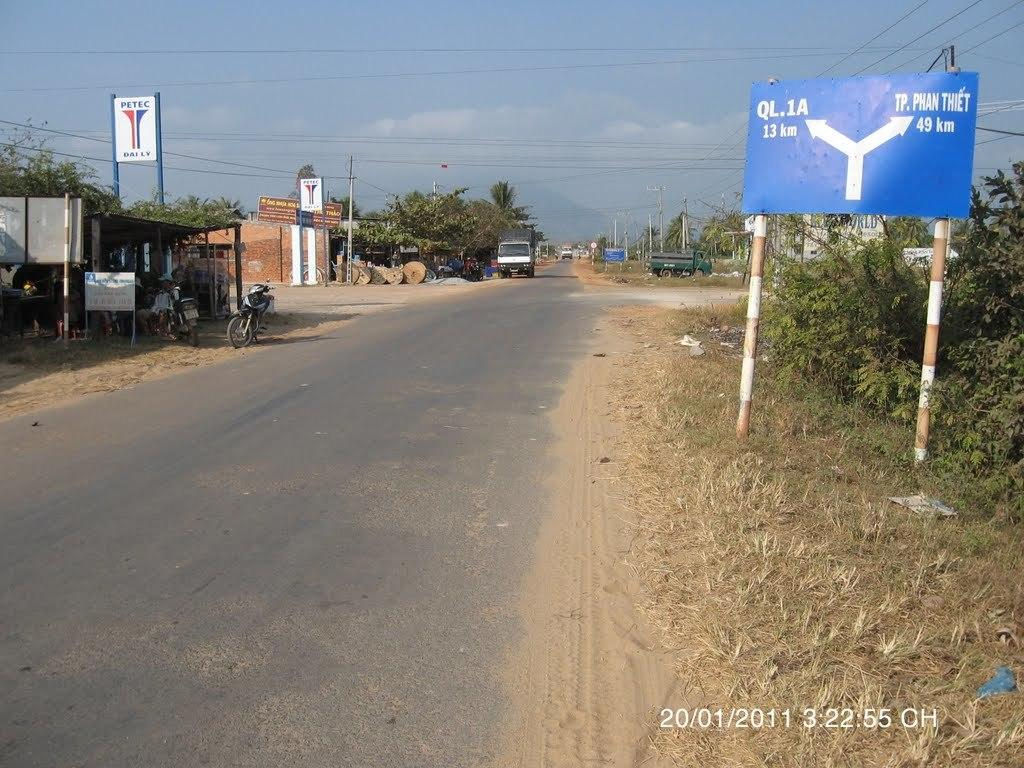<image>
Write a terse but informative summary of the picture. A sign on the side of the road says QL.1A is 13km to the left. 